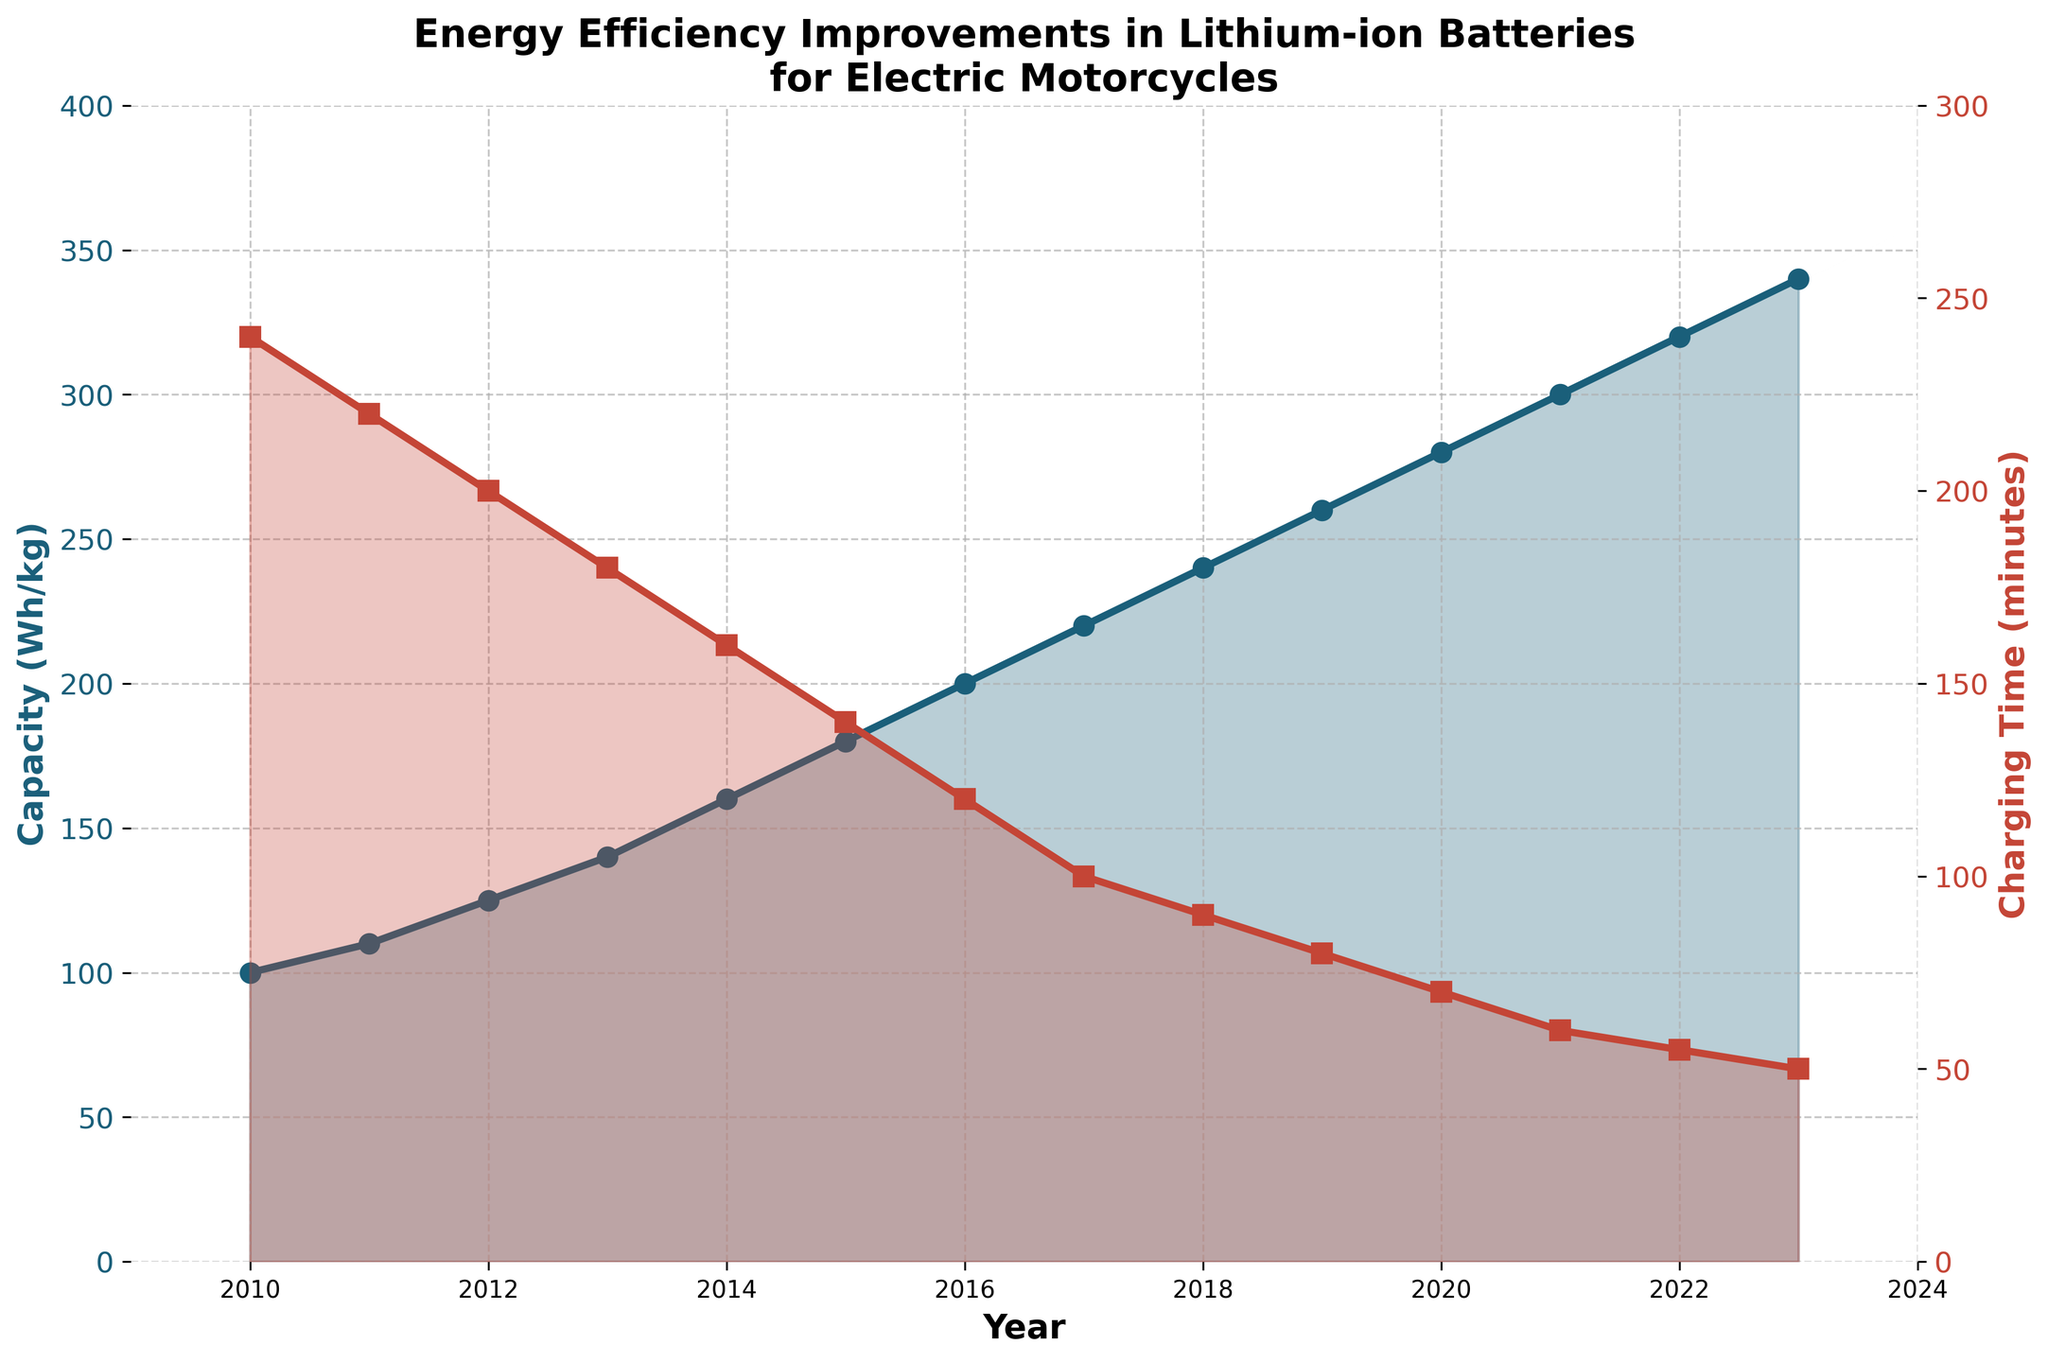How much did the capacity increase from 2010 to 2023? To determine the increase in capacity, subtract the 2010 capacity from the 2023 capacity: 340 Wh/kg - 100 Wh/kg.
Answer: 240 Wh/kg What was the charging time in 2016 and how does it compare to 2023? Look at the charging times for both years. In 2016, it was 120 minutes, and in 2023, it was 50 minutes. Compare the two values: 120 minutes is greater than 50 minutes.
Answer: 2016: 120 minutes, 2023: 50 minutes; 2016 was greater What is the average charging time from 2010 to 2023? Add all the charging times and divide by the number of years (14): (240 + 220 + 200 + 180 + 160 + 140 + 120 + 100 + 90 + 80 + 70 + 60 + 55 + 50) / 14 = 1445 / 14 = 103.21 minutes
Answer: 103.21 minutes Between which years did the capacity increase by 40 Wh/kg? Identify the years where the capacity increase is exactly 40 Wh/kg. From 2011 to 2013, it increased by 30 Wh/kg and from 2018 to 2020, it increased by 40 Wh/kg.
Answer: 2018 to 2020 What were the highest and lowest capacities reported in the figure? Look for the peak and the minimum values on the capacity line. The highest capacity is 340 Wh/kg in 2023 and the lowest is 100 Wh/kg in 2010.
Answer: Highest: 340 Wh/kg, Lowest: 100 Wh/kg Which year saw the maximum decrease in charging time compared to the previous year? Calculate the differences in charging time from year to year and identify the year with the largest drop. From 2021 to 2022, the decrease is 5 minutes which is the largest.
Answer: 2021 to 2022 How does the capacity in 2015 compare to that in 2011? Look at the capacities in 2015 and 2011. In 2015, it is 180 Wh/kg and in 2011, it is 110 Wh/kg. Compare these values: 180 Wh/kg is greater than 110 Wh/kg.
Answer: 2015: 180 Wh/kg, 2011: 110 Wh/kg; 2015 is greater What is the overall trend in charging time from 2010 to 2023? Observing the charging time line, it consistently decreases each year from 240 minutes in 2010 to 50 minutes in 2023, indicating a decreasing trend.
Answer: Decreasing What is the average capacity over the period shown? Add all the capacities and divide by the number of years (14): (100 + 110 + 125 + 140 + 160 + 180 + 200 + 220 + 240 + 260 + 280 + 300 + 320 + 340) / 14 = 2975 / 14 = 212.5 Wh/kg
Answer: 212.5 Wh/kg In which year did the charging time first drop below 100 minutes? Look at the charging times for each year and identify the first year where it is below 100 minutes. This first occurs in 2017.
Answer: 2017 